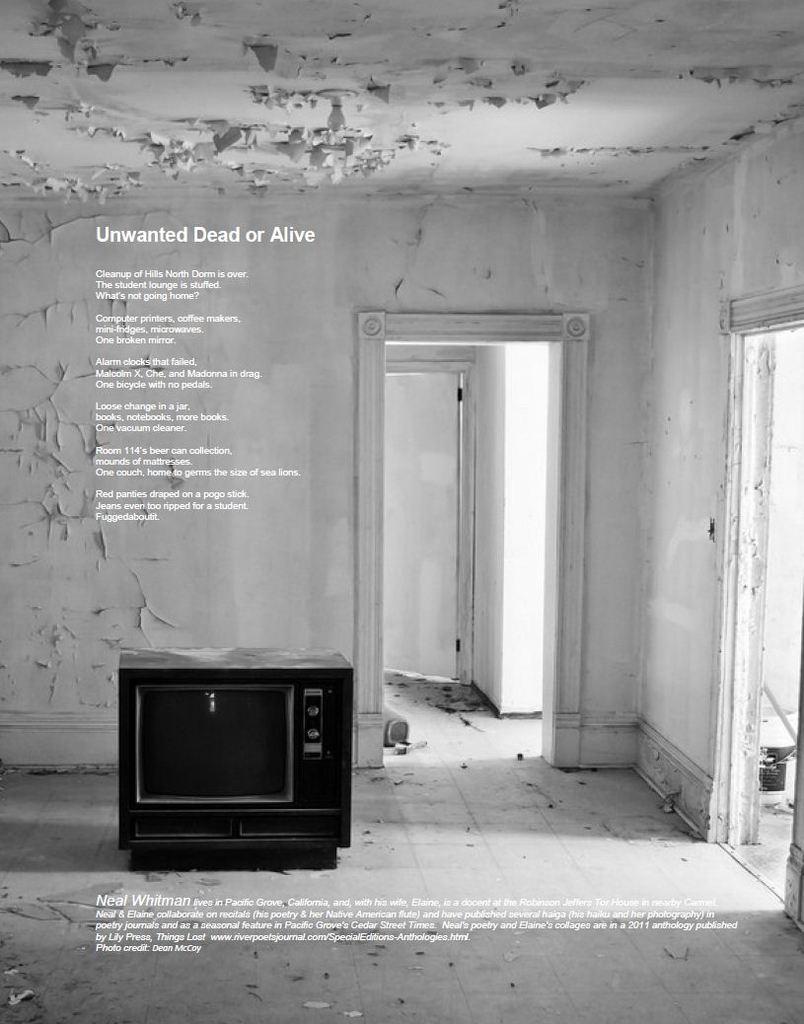What's the title of the poem?
Ensure brevity in your answer.  Unwanted dead or alive. 